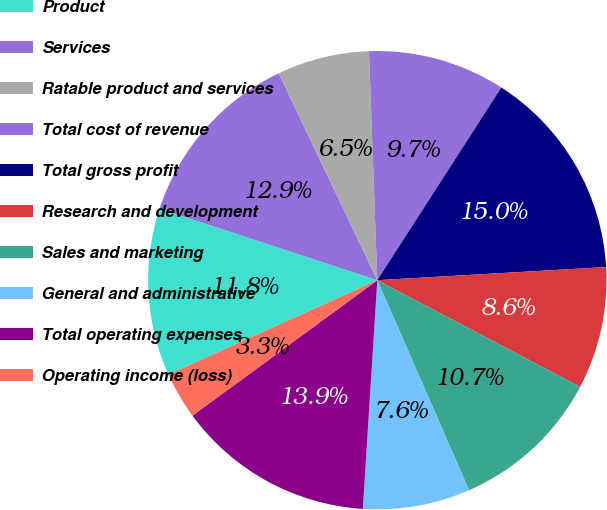Convert chart to OTSL. <chart><loc_0><loc_0><loc_500><loc_500><pie_chart><fcel>Product<fcel>Services<fcel>Ratable product and services<fcel>Total cost of revenue<fcel>Total gross profit<fcel>Research and development<fcel>Sales and marketing<fcel>General and administrative<fcel>Total operating expenses<fcel>Operating income (loss)<nl><fcel>11.81%<fcel>12.87%<fcel>6.5%<fcel>9.68%<fcel>14.99%<fcel>8.62%<fcel>10.74%<fcel>7.56%<fcel>13.93%<fcel>3.31%<nl></chart> 